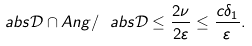<formula> <loc_0><loc_0><loc_500><loc_500>\ a b s { \mathcal { D } \cap A n g } / \ a b s { \mathcal { D } } \leq \frac { 2 \nu } { 2 \varepsilon } \leq \frac { c \delta _ { 1 } } { \varepsilon } .</formula> 